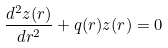Convert formula to latex. <formula><loc_0><loc_0><loc_500><loc_500>\frac { d ^ { 2 } z ( r ) } { d r ^ { 2 } } + q ( r ) z ( r ) = 0</formula> 